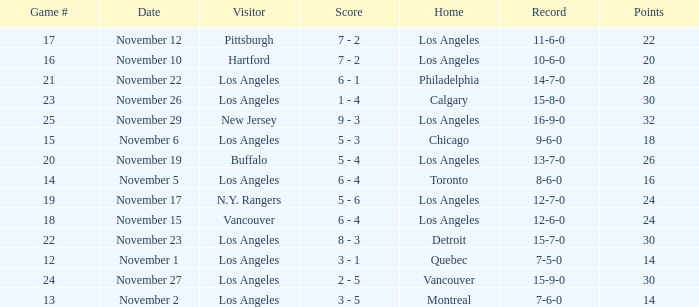What is the number of points of the game less than number 17 with an 11-6-0 record? None. 